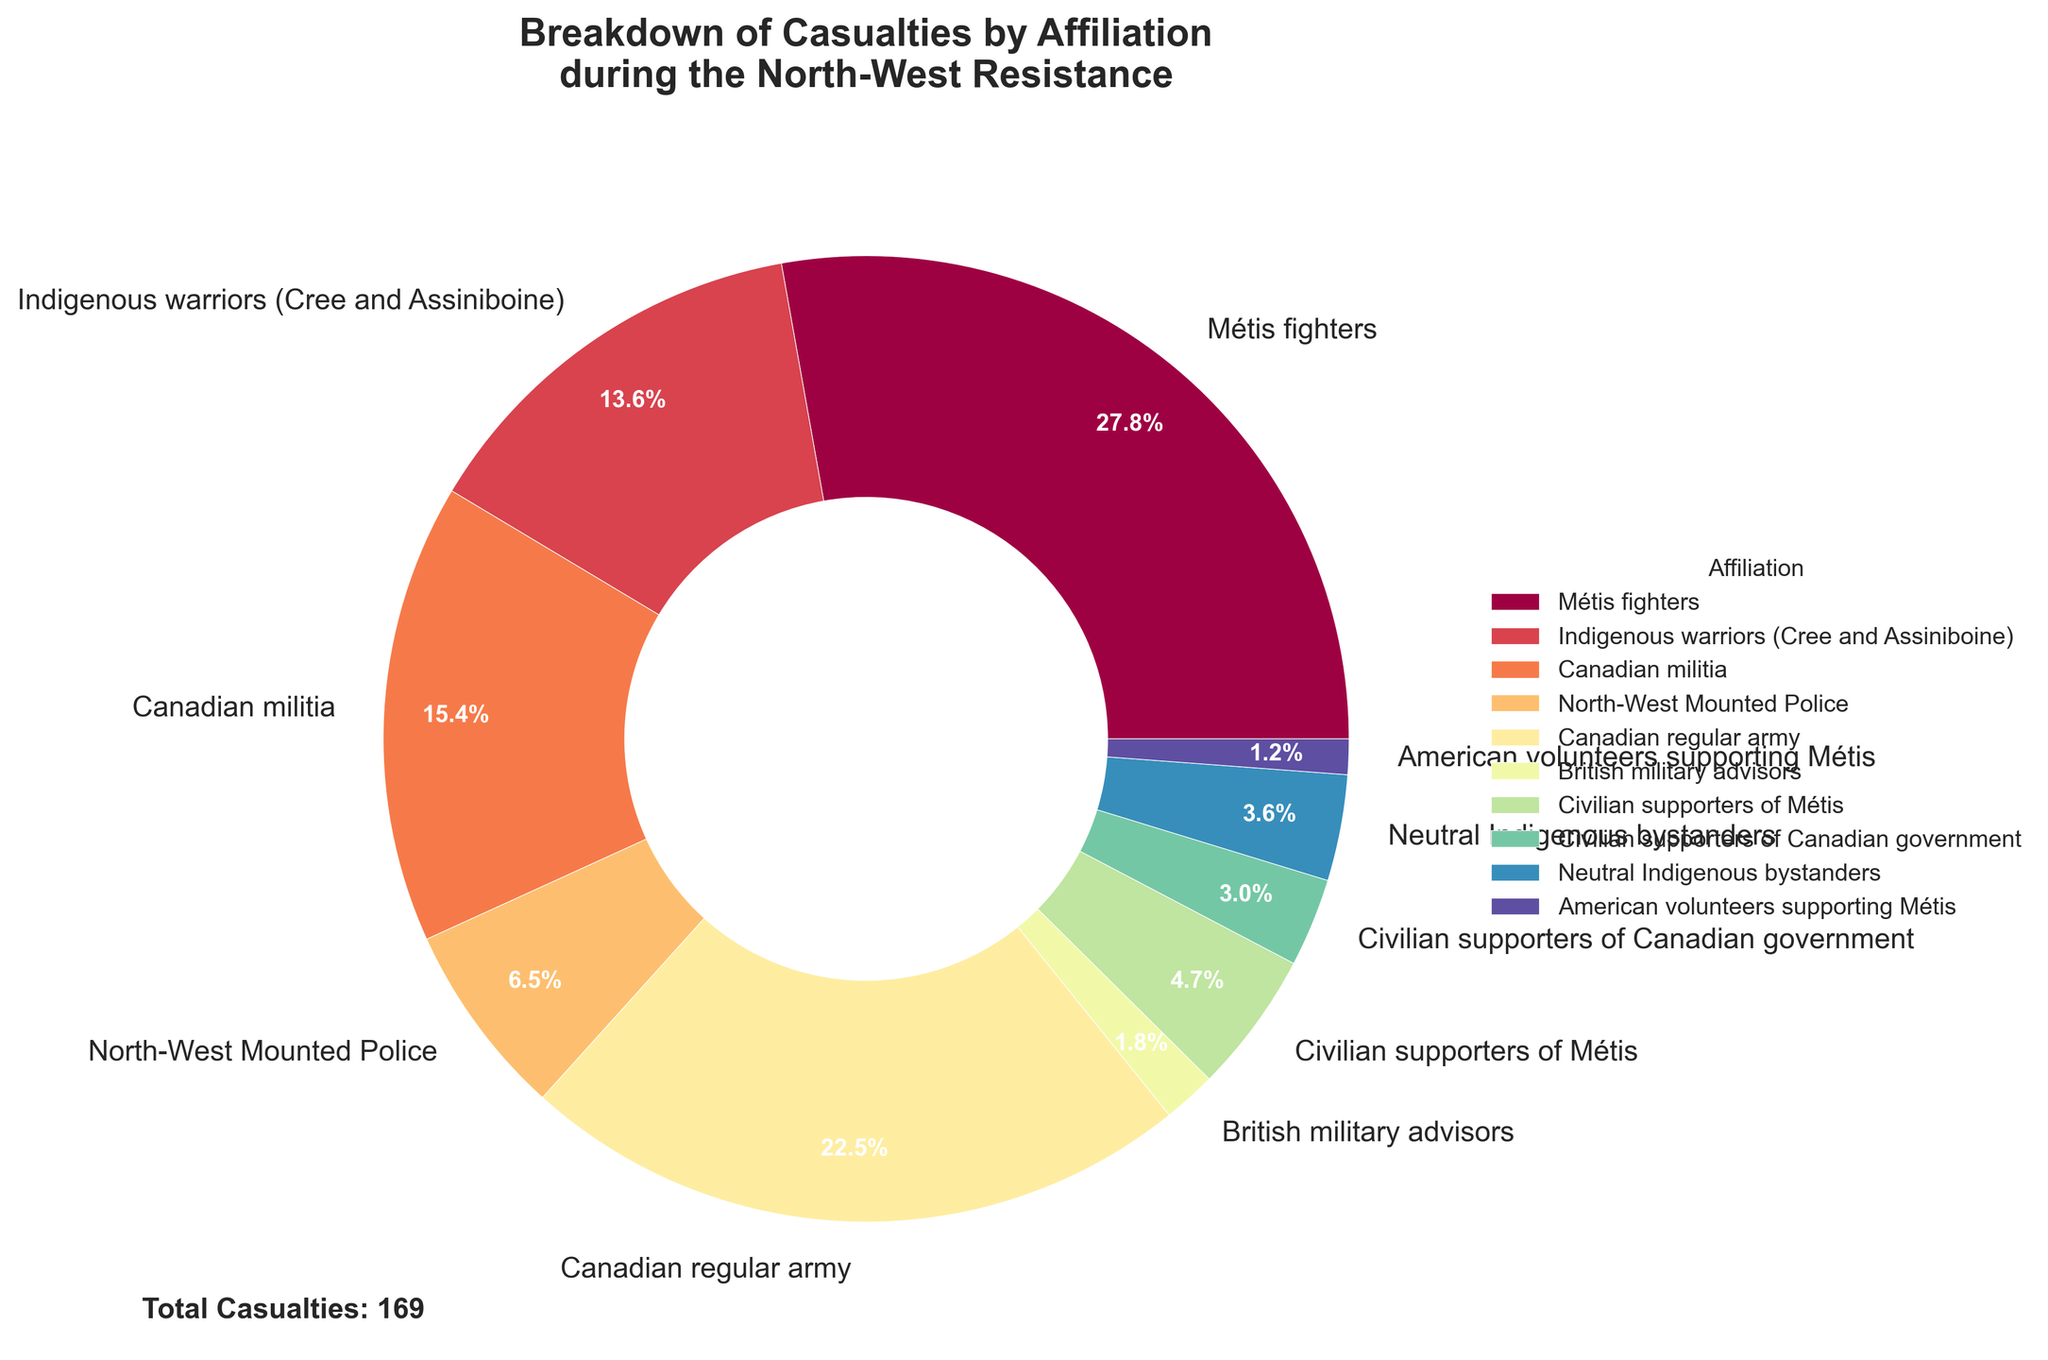What's the total number of casualties attributed to Canadian forces, including the militia, North-West Mounted Police, and regular army? Add the casualties from Canadian militia (26), North-West Mounted Police (11), and Canadian regular army (38): 26 + 11 + 38 = 75
Answer: 75 Which group has the highest percentage of casualties? By looking at the pie chart, identify the wedge with the largest percentage. Métis fighters have the highest percentage of casualties at 47 out of 169, which is 27.8%.
Answer: Métis fighters Are the casualties of Indigenous warriors (Cree and Assiniboine) greater than Canadian militia? Compare the size of the wedges representing casualties for Indigenous warriors (23) and Canadian militia (26). Since 23 is less than 26, the answer is no.
Answer: No What is the combined percentage of casualties for Neutral Indigenous bystanders and American volunteers supporting Métis? Calculate the combined percentage: Neutral Indigenous bystanders (6 out of 169, approximately 3.6%) and American volunteers supporting Métis (2 out of 169, approximately 1.2%). Combined, this is 3.6% + 1.2% = 4.8%.
Answer: 4.8% How many more casualties were there for the Canadian regular army compared to the North-West Mounted Police? Subtract the casualties of the North-West Mounted Police (11) from those of the Canadian regular army (38): 38 - 11 = 27
Answer: 27 Which two groups have the closest number of casualties, and what are those numbers? Compare the casualty numbers of each group and identify the two closest. Civilian supporters of Métis (8) and Neutral Indigenous bystanders (6) are closest with differences of 2.
Answer: Civilian supporters of Métis and Neutral Indigenous bystanders, 8 and 6 Is the percentage of Métis fighters' casualties more than half of the total casualties? Calculate half of the total casualties: 169 / 2 = 84.5. Métis fighters have 47 casualties, which is less than 84.5; thus, it is not more than half.
Answer: No Which group has the smallest number of casualties, and what percentage of the total does this represent? Identify the wedge with the smallest number. American volunteers supporting Métis have the smallest number of casualties (2), which is approximately 2 / 169 = 1.2%.
Answer: American volunteers supporting Métis, 1.2% What's the difference in casualties between civilian supporters of Métis and civilian supporters of the Canadian government? Subtract the casualties of civilian supporters of the Canadian government (5) from those of civilian supporters of Métis (8): 8 - 5 = 3
Answer: 3 